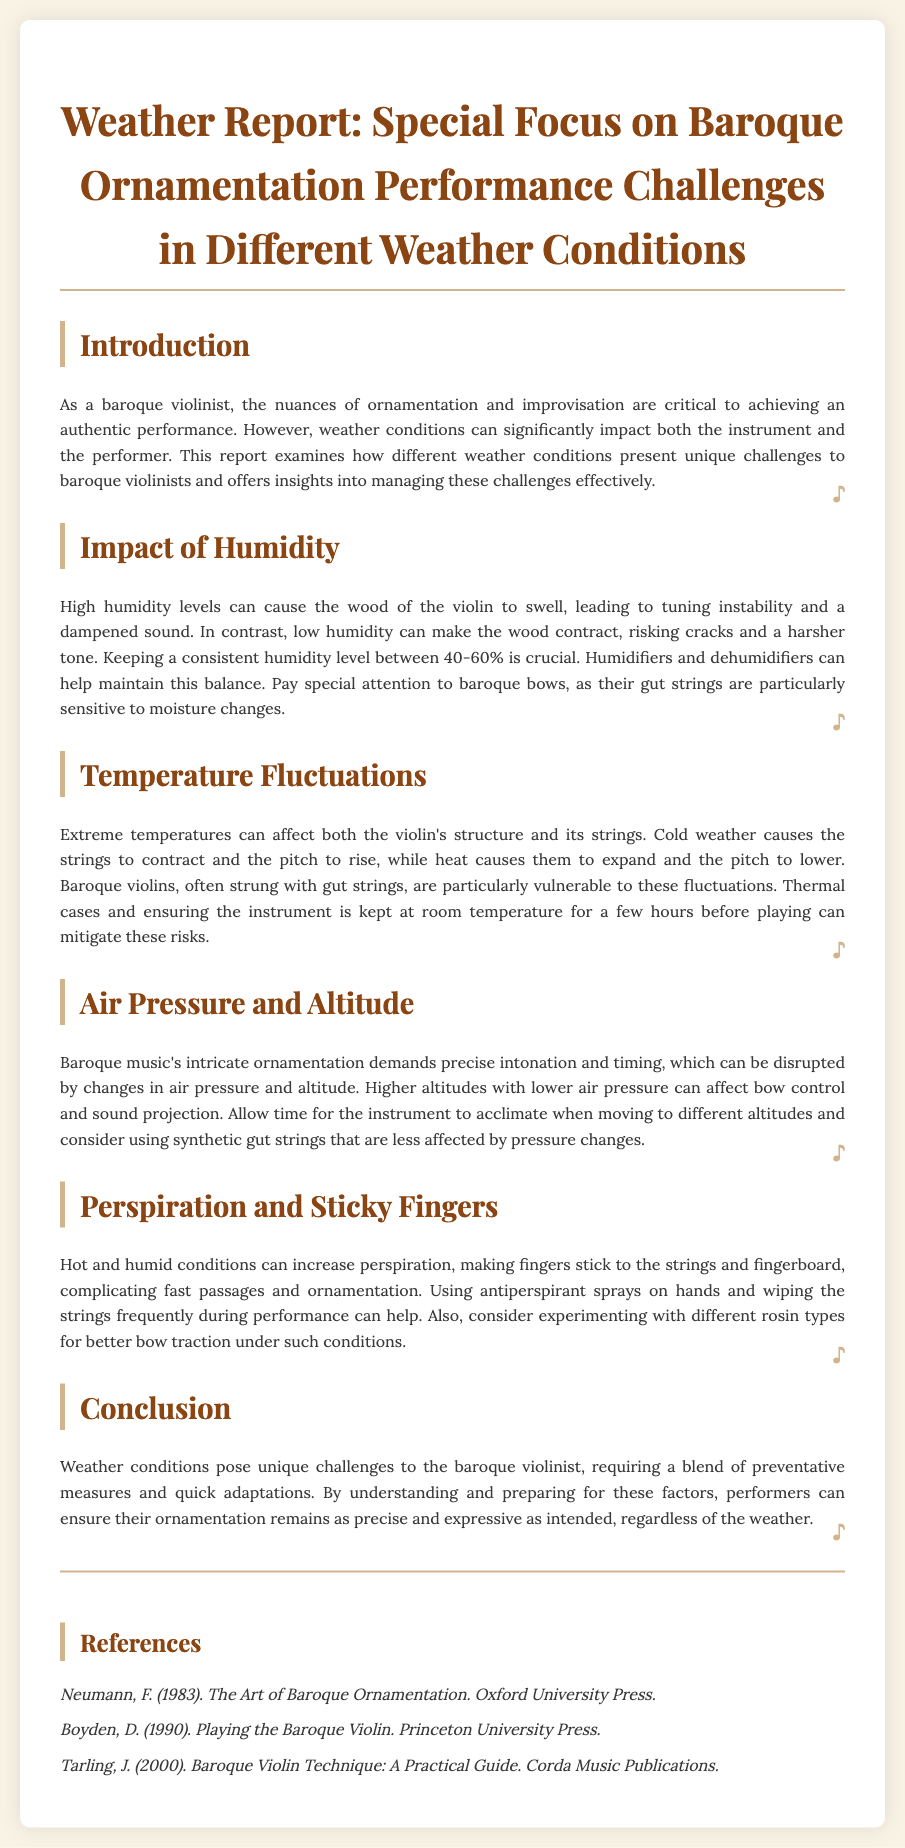What is a critical humidity level for baroque violins? The document states that keeping a consistent humidity level between 40-60% is crucial for baroque violins.
Answer: 40-60% What can high humidity levels cause in a violin? High humidity levels can cause the wood of the violin to swell, leading to tuning instability and a dampened sound.
Answer: Tuning instability What should be used to mitigate extreme temperature risks? The report suggests using thermal cases and keeping the instrument at room temperature for a few hours to mitigate temperature risks.
Answer: Thermal cases What is affected by higher altitudes according to the report? The document mentions that higher altitudes with lower air pressure can affect bow control and sound projection for baroque violinists.
Answer: Bow control What can increase perspiration during performances? The document notes that hot and humid conditions can increase perspiration for musicians performing.
Answer: Hot and humid conditions Which type of strings are less affected by pressure changes? The report indicates that synthetic gut strings are less affected by pressure changes than traditional strings.
Answer: Synthetic gut strings What is a recommended measure for sticky fingers during performances? The document suggests using antiperspirant sprays on hands to manage sticky fingers while playing.
Answer: Antiperspirant sprays What is the main focus of the weather report? The overview emphasizes the unique challenges faced by baroque violinists due to different weather conditions.
Answer: Performance challenges Who authored "The Art of Baroque Ornamentation"? The document lists Frank Neumann as the author of "The Art of Baroque Ornamentation".
Answer: Frank Neumann 